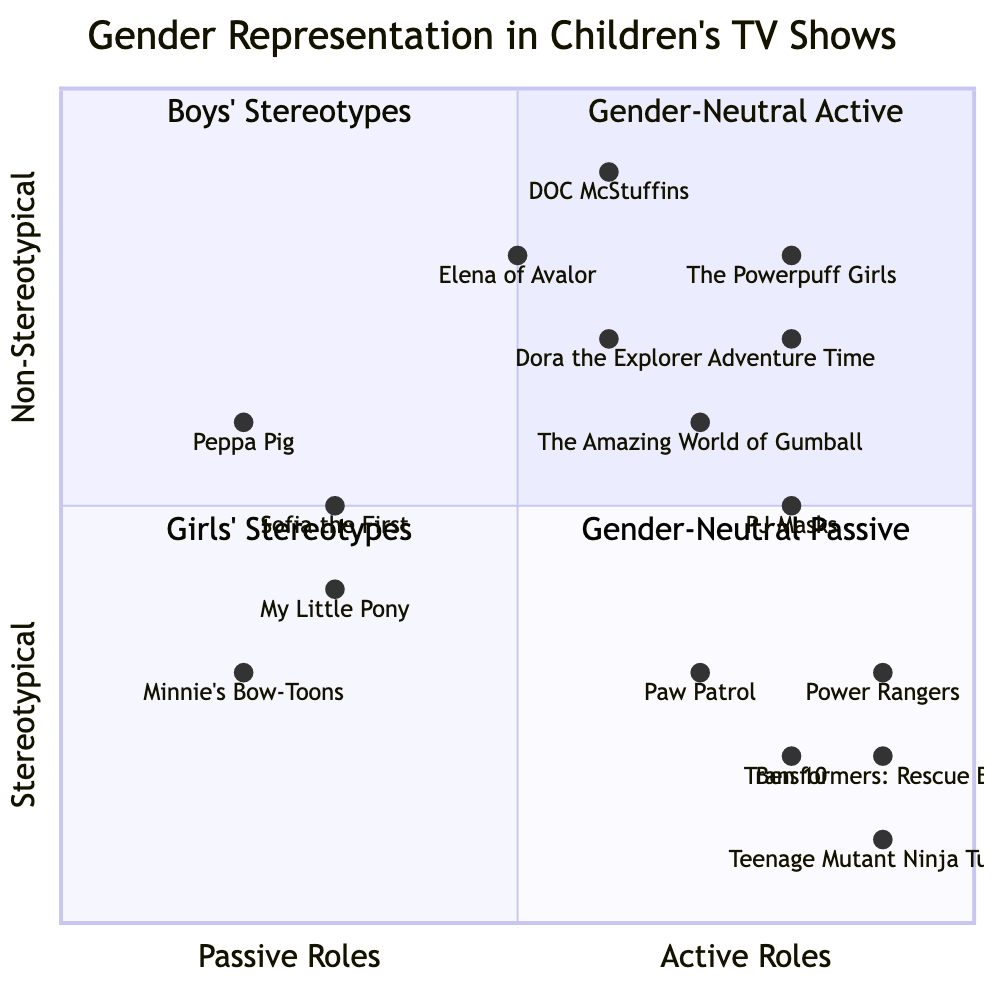What shows are in the "Boys' Stereotypes" quadrant? The "Boys' Stereotypes" quadrant includes shows like "Transformers: Rescue Bots", "Power Rangers", "Teenage Mutant Ninja Turtles", and "PJ Masks". Upon analyzing the chart, these shows are located in the quadrant where they depict boys engaged in active roles while conforming to stereotypical behavior.
Answer: Transformers: Rescue Bots, Power Rangers, Teenage Mutant Ninja Turtles, PJ Masks Which show represents a gender-neutral active role? The "Gender-Neutral Active" quadrant features shows such as "The Powerpuff Girls" and "PJ Masks". By checking the coordinates of the shows on the chart, we can see that they fall into a quadrant defined by active roles while also demonstrating gender-neutral characteristics.
Answer: The Powerpuff Girls, PJ Masks How many shows are depicted in the "Girls' Stereotypes" quadrant? The "Girls' Stereotypes" quadrant contains shows like "Dora the Explorer", "My Little Pony", "Peppa Pig", and "Sofia the First". Counting these shows gives us a total of four located in this quadrant, characterized by passive roles and stereotypical representation of girls.
Answer: 4 Which show expresses a wider range of emotions according to the chart? According to the chart, "Elena of Avalor" is indicated in the portion representing girls expressing a wider range of emotions. By analyzing the emotional expression data, we see this show is placed where girls are shown with broader emotional experiences.
Answer: Elena of Avalor What are the example shows for "Lead Roles" about males? The example shows for "Lead Roles" about males include "Paw Patrol" and "Ben 10". In examining the data, these shows highlight predominantly male lead characters, representing a traditional gender role in children's media.
Answer: Paw Patrol, Ben 10 